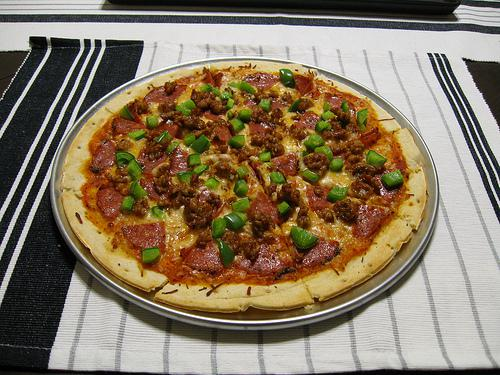Question: how is the pizza sliced?
Choices:
A. Rectangles.
B. In eighths.
C. In triangles.
D. With pizza knife.
Answer with the letter. Answer: C Question: what toppings are on the pizza?
Choices:
A. Peppers.
B. Onions.
C. Pineapple.
D. Meat, vegetables, cheese.
Answer with the letter. Answer: D Question: what food item is this?
Choices:
A. Brocolli.
B. Ice cream.
C. Pizza.
D. Sausage.
Answer with the letter. Answer: C Question: what pattern is the table cloth?
Choices:
A. Plaid.
B. Flowers.
C. Herringbone.
D. Stripes.
Answer with the letter. Answer: D Question: what color is the pizza tray?
Choices:
A. Silver.
B. Black.
C. Brown.
D. White.
Answer with the letter. Answer: A 